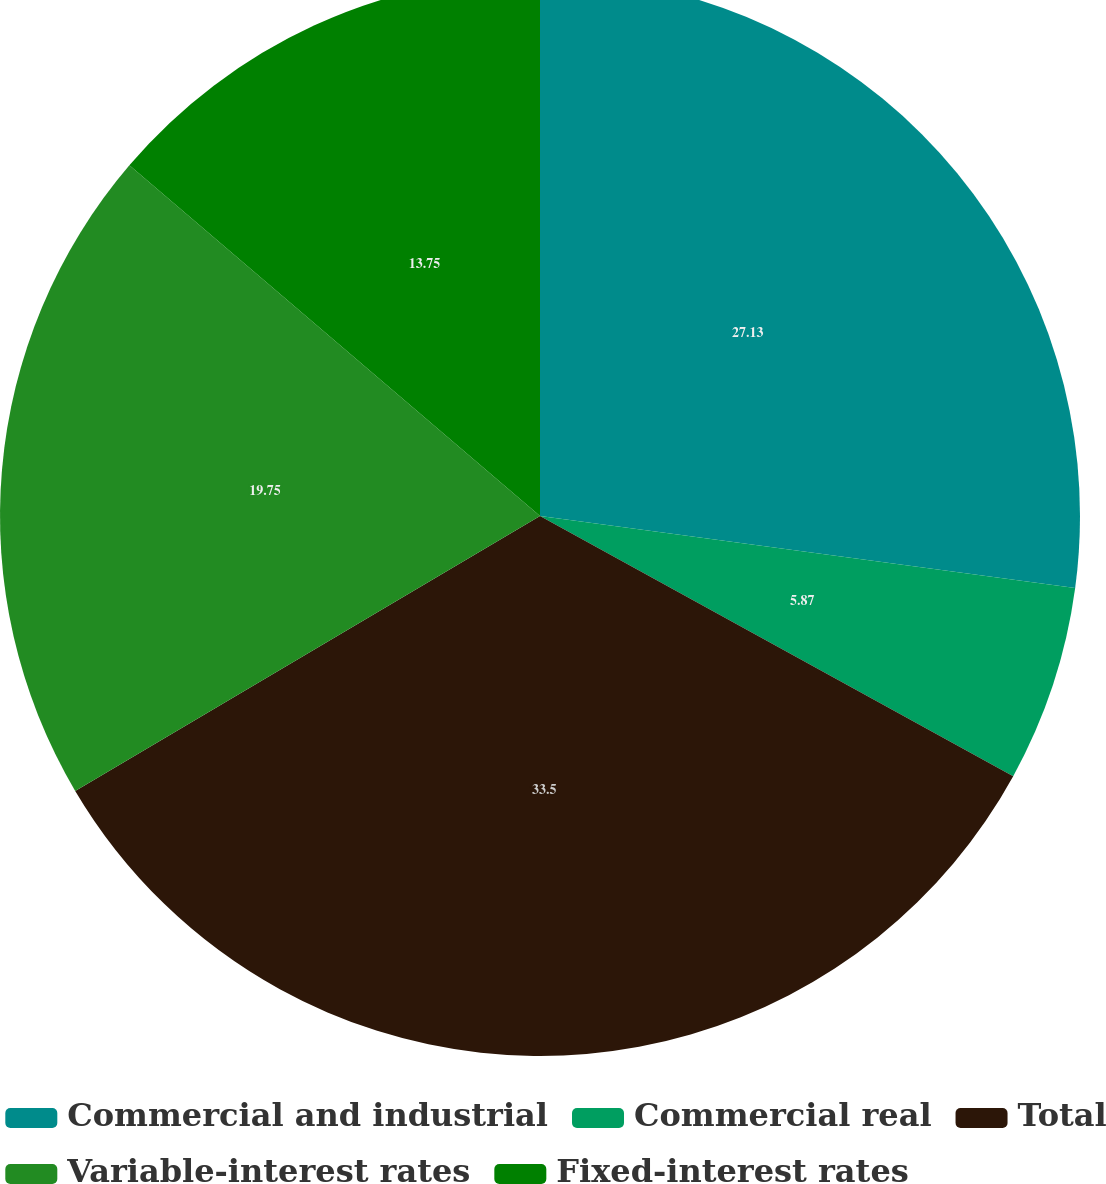Convert chart. <chart><loc_0><loc_0><loc_500><loc_500><pie_chart><fcel>Commercial and industrial<fcel>Commercial real<fcel>Total<fcel>Variable-interest rates<fcel>Fixed-interest rates<nl><fcel>27.13%<fcel>5.87%<fcel>33.5%<fcel>19.75%<fcel>13.75%<nl></chart> 